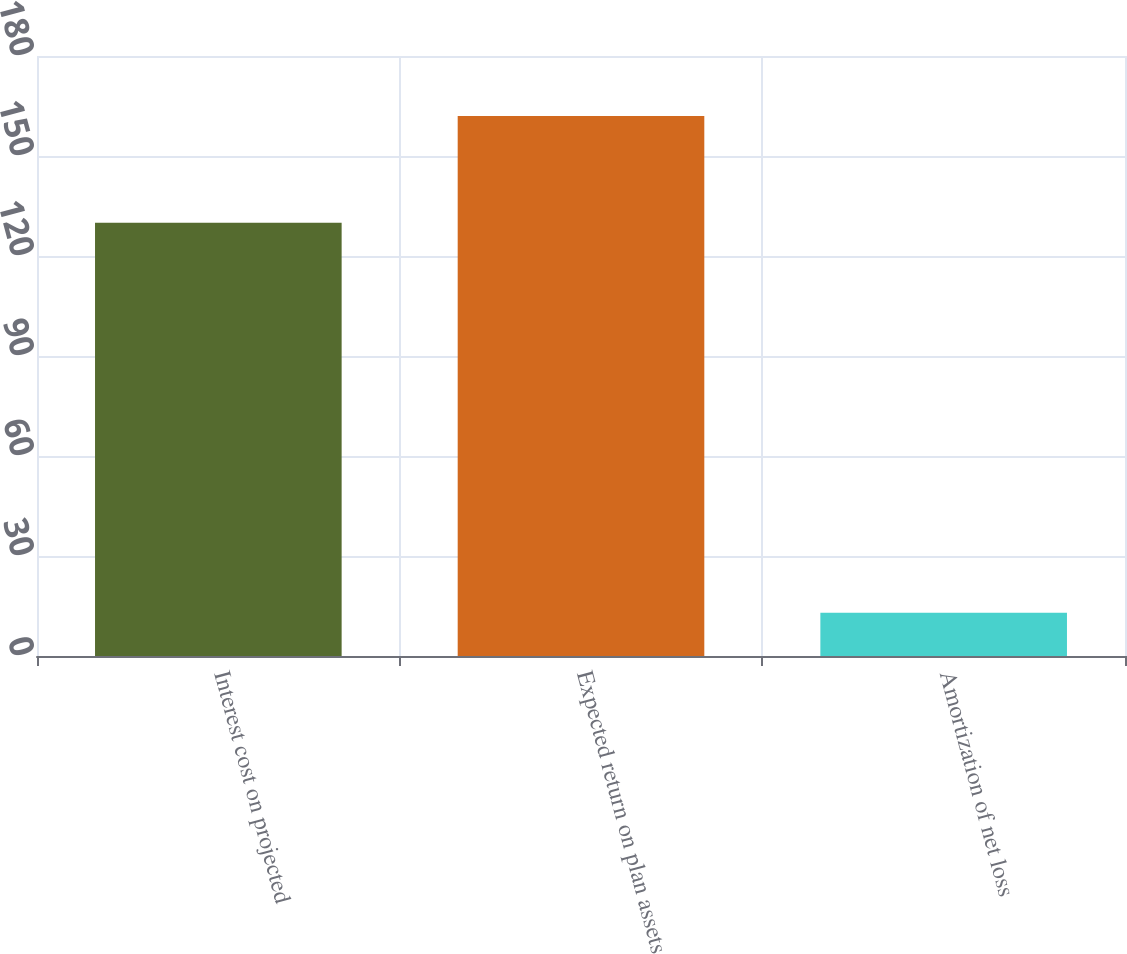Convert chart. <chart><loc_0><loc_0><loc_500><loc_500><bar_chart><fcel>Interest cost on projected<fcel>Expected return on plan assets<fcel>Amortization of net loss<nl><fcel>130<fcel>162<fcel>13<nl></chart> 